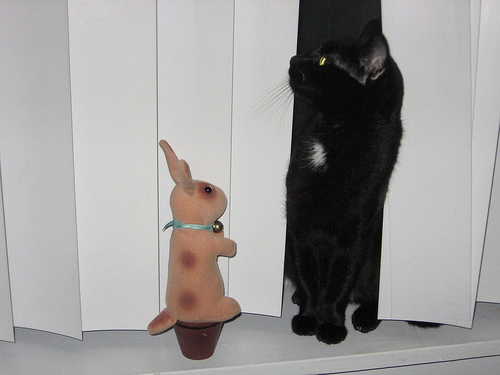<image>
Can you confirm if the fake rabbit is to the left of the cat? Yes. From this viewpoint, the fake rabbit is positioned to the left side relative to the cat. Is there a flower pot under the bunny? Yes. The flower pot is positioned underneath the bunny, with the bunny above it in the vertical space. 